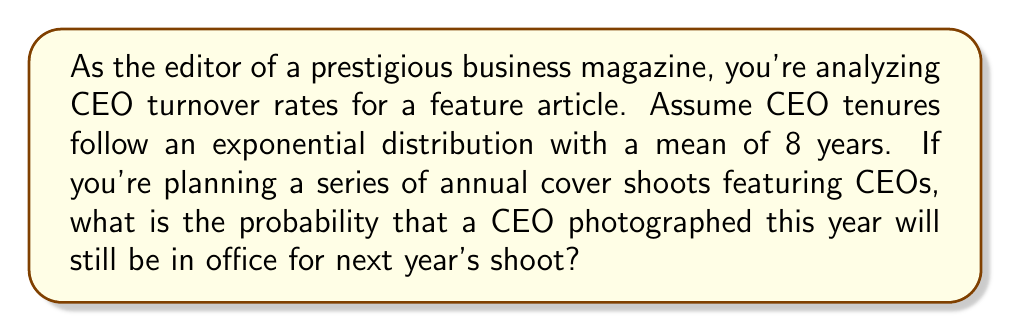Help me with this question. Let's approach this step-by-step using renewal process theory:

1) The exponential distribution is memoryless, which means the probability of a CEO remaining in office for another year is the same regardless of how long they've been in the position.

2) Given:
   - CEO tenures follow an exponential distribution
   - Mean tenure (λ) = 8 years

3) For an exponential distribution, the probability of an event lasting longer than time t is given by:

   $$P(T > t) = e^{-\frac{t}{\lambda}}$$

   where λ is the mean of the distribution.

4) In this case, we want to know the probability of a CEO lasting at least one more year:

   $$P(T > 1) = e^{-\frac{1}{8}}$$

5) Calculate:

   $$P(T > 1) = e^{-0.125} \approx 0.8825$$

Thus, there's approximately an 88.25% chance that a CEO photographed this year will still be in office for next year's shoot.
Answer: $e^{-\frac{1}{8}} \approx 0.8825$ or 88.25% 